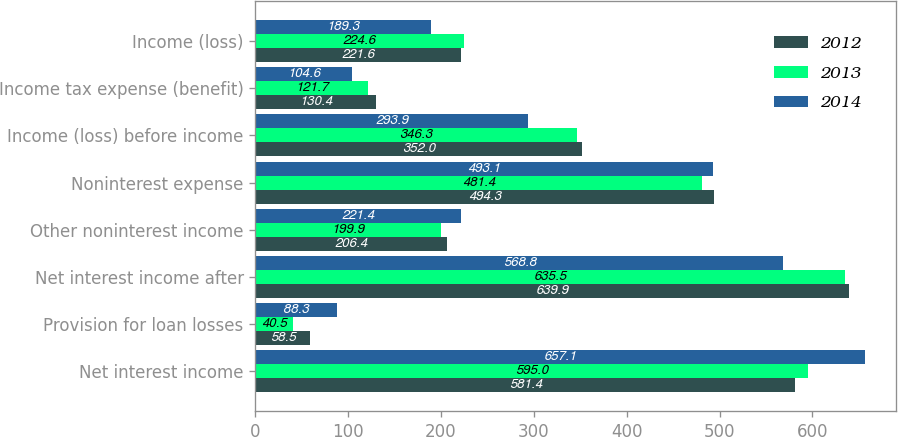Convert chart. <chart><loc_0><loc_0><loc_500><loc_500><stacked_bar_chart><ecel><fcel>Net interest income<fcel>Provision for loan losses<fcel>Net interest income after<fcel>Other noninterest income<fcel>Noninterest expense<fcel>Income (loss) before income<fcel>Income tax expense (benefit)<fcel>Income (loss)<nl><fcel>2012<fcel>581.4<fcel>58.5<fcel>639.9<fcel>206.4<fcel>494.3<fcel>352<fcel>130.4<fcel>221.6<nl><fcel>2013<fcel>595<fcel>40.5<fcel>635.5<fcel>199.9<fcel>481.4<fcel>346.3<fcel>121.7<fcel>224.6<nl><fcel>2014<fcel>657.1<fcel>88.3<fcel>568.8<fcel>221.4<fcel>493.1<fcel>293.9<fcel>104.6<fcel>189.3<nl></chart> 